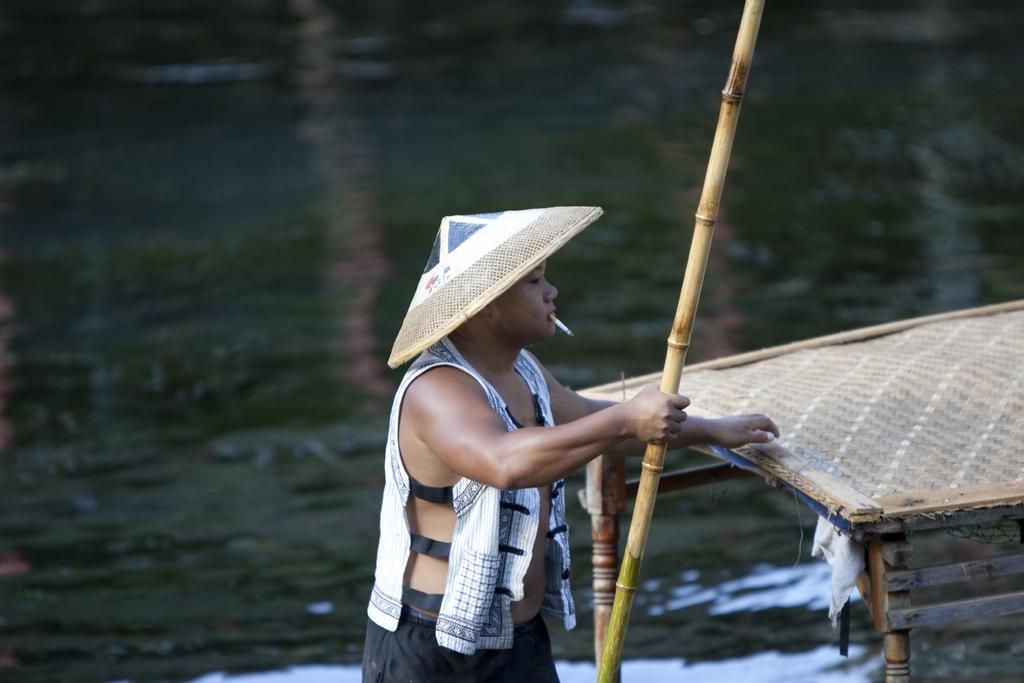Please provide a concise description of this image. In this picture we can see a person holding a stick. There is a cigarette in his mouth. We can see a wooden object on the right side. 